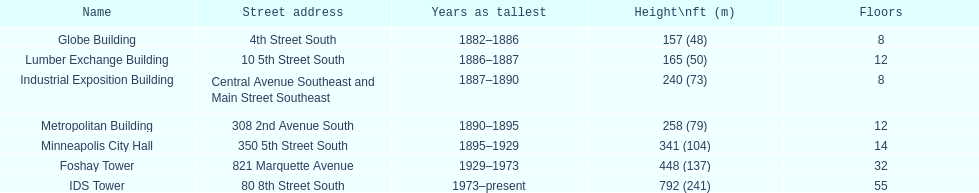Which is taller, the metropolitan building or the lumber exchange building? Metropolitan Building. 